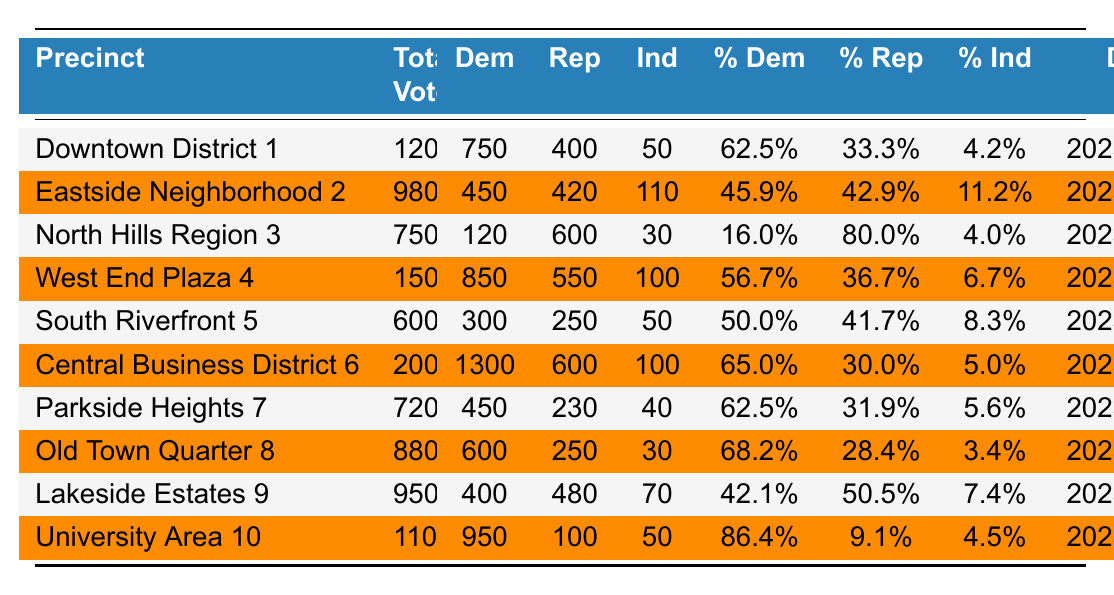What precinct had the highest total votes in 2023? The precincts are listed with their total votes. Looking through the list, "Central Business District 6" has the highest total votes with 2000.
Answer: Central Business District 6 What percentage of votes did Democrats receive in the University Area 10 precinct? In the University Area 10 precinct, Democrats received 86.4% of the votes as indicated in the table.
Answer: 86.4% How many more Republican votes were there in North Hills Region 3 than Democratic votes? In North Hills Region 3, Democrats received 120 votes and Republicans received 600 votes. The difference is 600 - 120 = 480.
Answer: 480 Which precinct had the lowest percentage of Democratic votes? By examining the percentages, North Hills Region 3 has the lowest percentage of Democratic votes at 16.0%.
Answer: North Hills Region 3 What is the total number of votes cast for Independents across all precincts? We need to add the independent votes from each precinct: 50 + 110 + 30 + 100 + 50 + 100 + 40 + 30 + 70 + 50 = 730.
Answer: 730 Did any precinct have more than 100 independent votes? Checking the independent vote counts, "Eastside Neighborhood 2," "Central Business District 6," and "University Area 10" all had more than 100 independent votes. Hence, there are precincts with over 100 independent votes.
Answer: Yes What is the average percentage of Republican votes across all precincts? To find the average, sum the Republican percentages: (33.3 + 42.9 + 80.0 + 36.7 + 41.7 + 30.0 + 31.9 + 28.4 + 50.5 + 9.1) = 400.5. There are 10 precincts, so the average is 400.5 / 10 = 40.05%.
Answer: 40.05% Which precincts had a Democratic vote percentage of 60% or higher? The precincts with Democratic vote percentages of 60% or higher are: "Downtown District 1" (62.5%), "West End Plaza 4" (56.7%), "Central Business District 6" (65.0%), "Parkside Heights 7" (62.5%), "Old Town Quarter 8" (68.2%), and "University Area 10" (86.4%).
Answer: Downtown District 1, West End Plaza 4, Central Business District 6, Parkside Heights 7, Old Town Quarter 8, University Area 10 What percentage of total votes were cast for Democrats in the Eastside Neighborhood 2? In Eastside Neighborhood 2, the percentage of votes for Democrats is 45.9%, as shown in the table.
Answer: 45.9% If we combine all Democratic votes from the precincts, how many total Democratic votes were cast? Add the Democratic votes from each precinct: 750 + 450 + 120 + 850 + 300 + 1300 + 450 + 600 + 400 + 950 = 8750.
Answer: 8750 